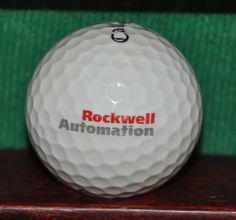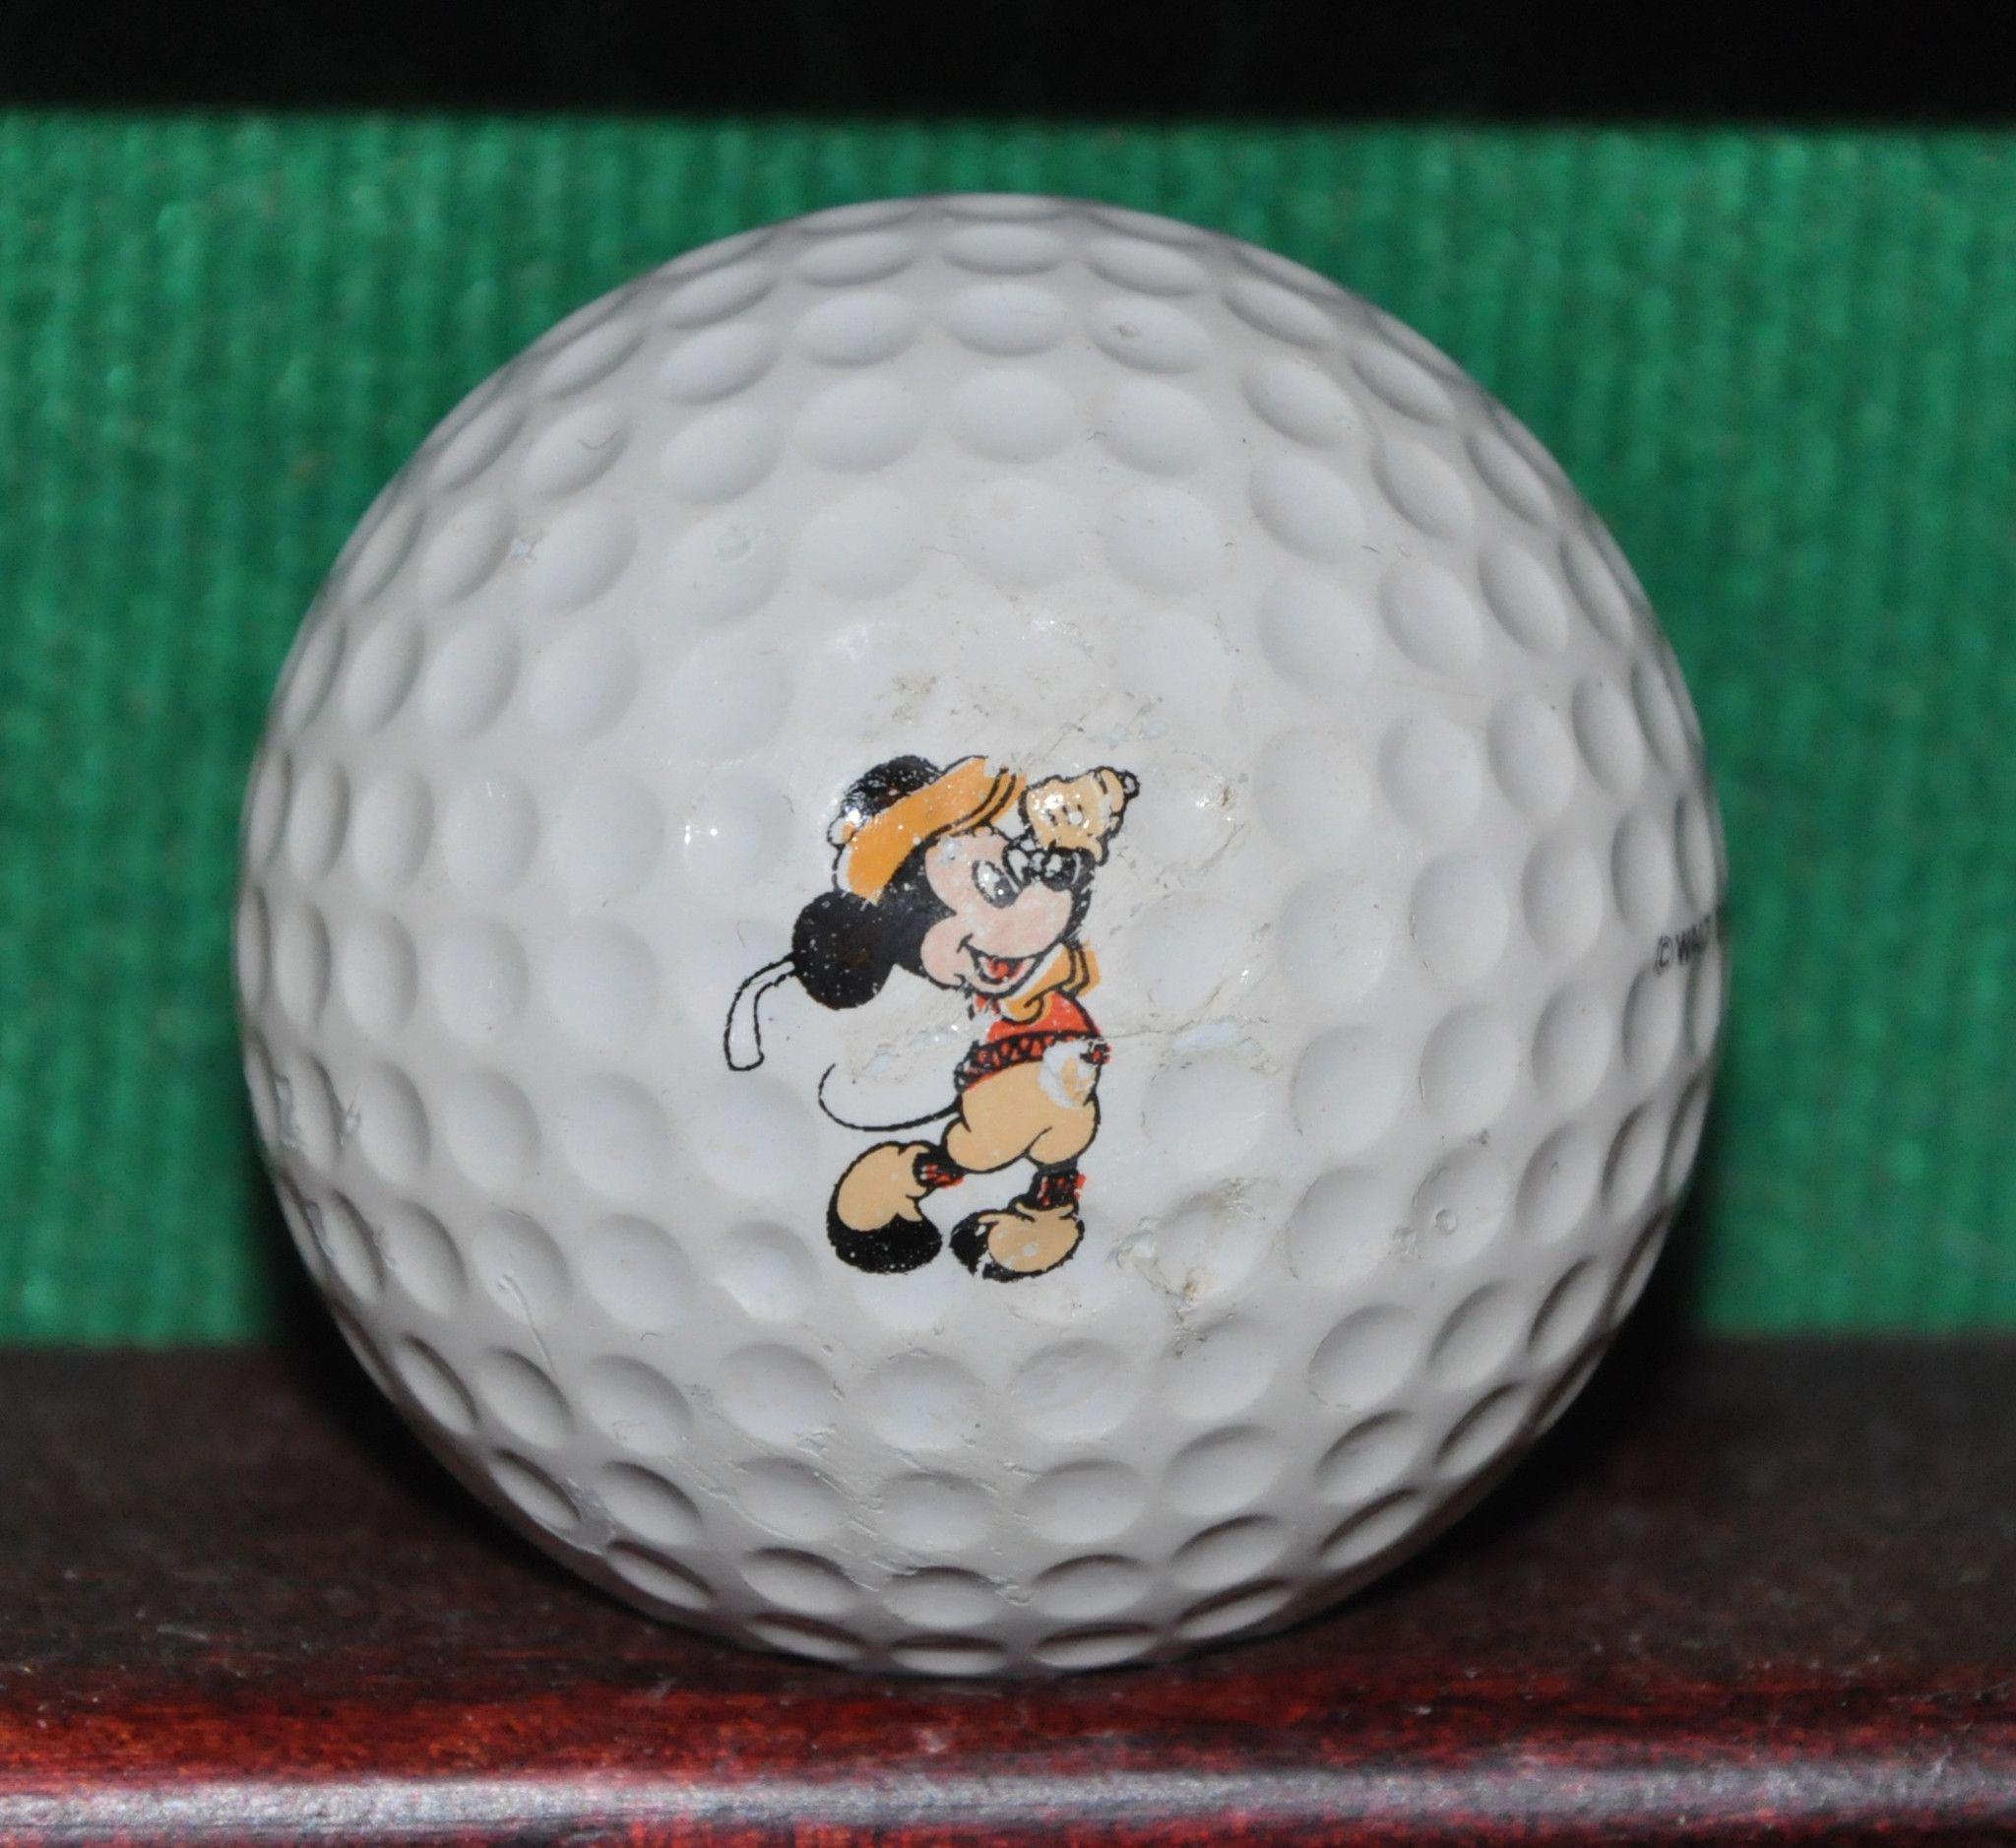The first image is the image on the left, the second image is the image on the right. Given the left and right images, does the statement "One image in the pair contains golf balls inside packaging." hold true? Answer yes or no. No. 